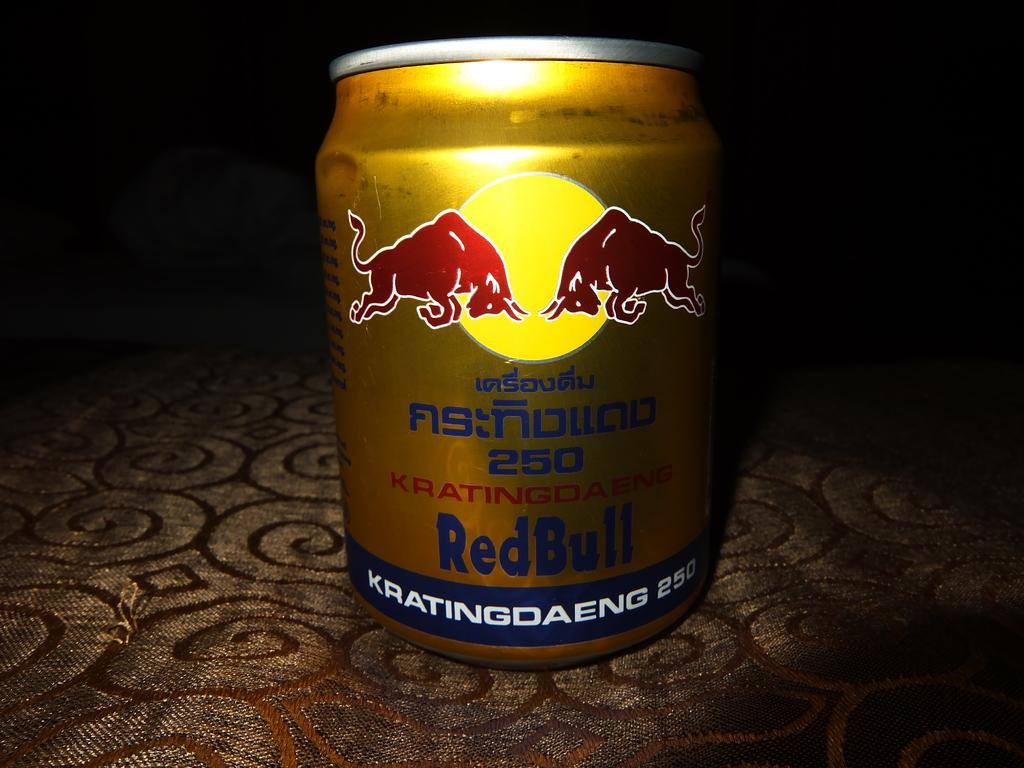<image>
Summarize the visual content of the image. a red bull container that is on a surface 